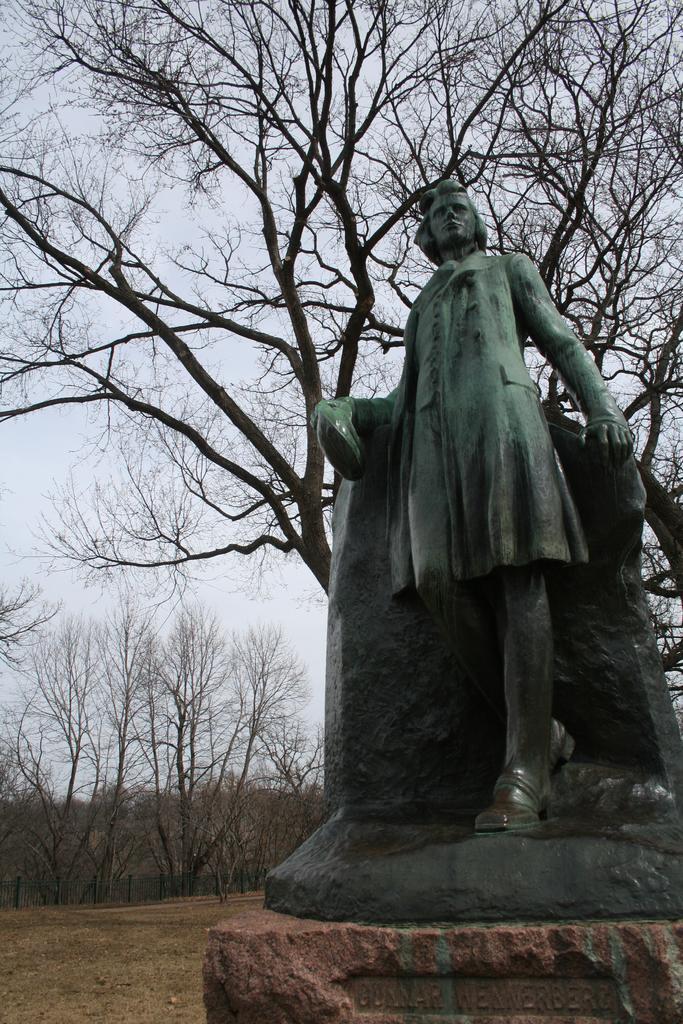How would you summarize this image in a sentence or two? In the image in the center, we can see one stone and one statue, which is in green color. In the background we can see the sky, clouds and trees. 